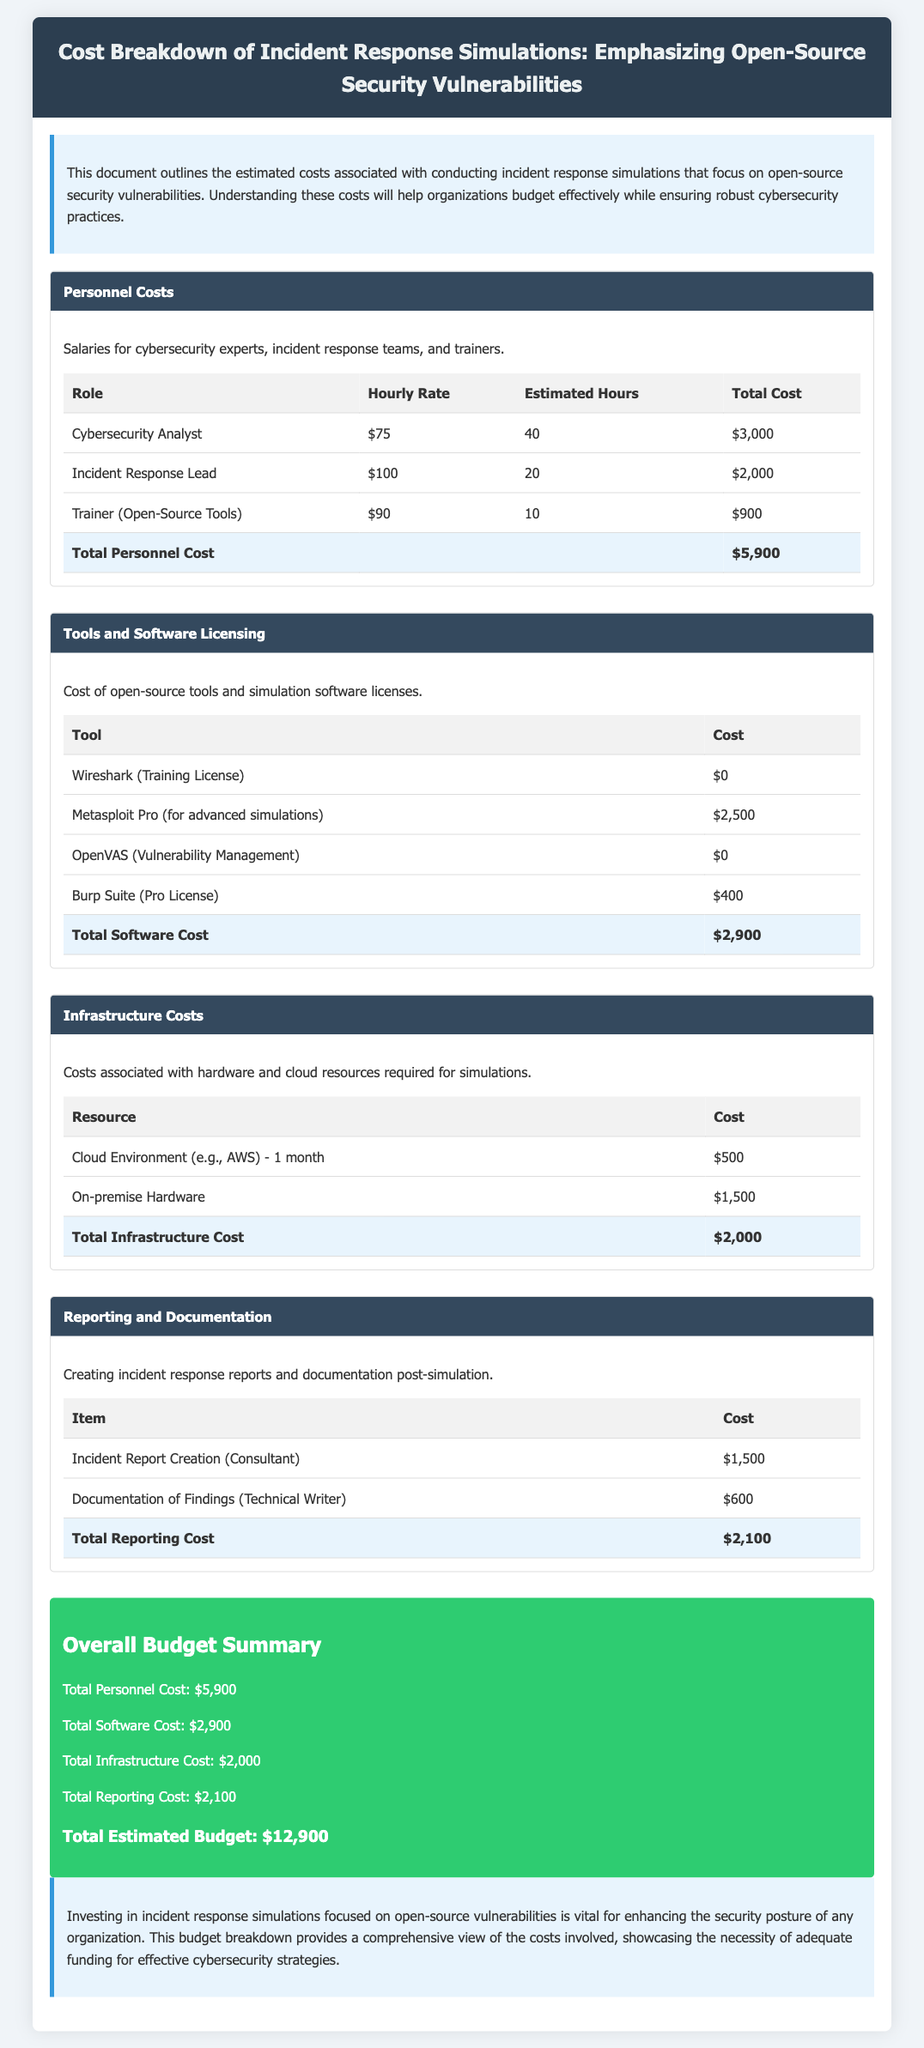What is the total personnel cost? The total personnel cost is specified in the budget as $5,900.
Answer: $5,900 How much does the Metasploit Pro tool cost? The document lists the cost of Metasploit Pro as $2,500.
Answer: $2,500 What is the cost for cloud infrastructure for one month? The cloud environment cost is outlined as $500 for one month.
Answer: $500 Who is the trainer for open-source tools? The document specifies the role as Trainer (Open-Source Tools).
Answer: Trainer (Open-Source Tools) What is the total estimated budget for the incident response simulations? The overall budget summary calculates the total estimated budget to be $12,900.
Answer: $12,900 What is the purpose of the incident report creation? The incident report creation is mentioned for creating incident response reports and documentation.
Answer: Incident response reports How many estimated hours does the Incident Response Lead work? The estimated hours for the Incident Response Lead are listed as 20.
Answer: 20 Which open-source tool has a training license cost of $0? The document mentions that Wireshark has a training license cost of $0.
Answer: Wireshark What is the total cost of tools and software licensing? The total cost for tools and software licensing is detailed as $2,900.
Answer: $2,900 